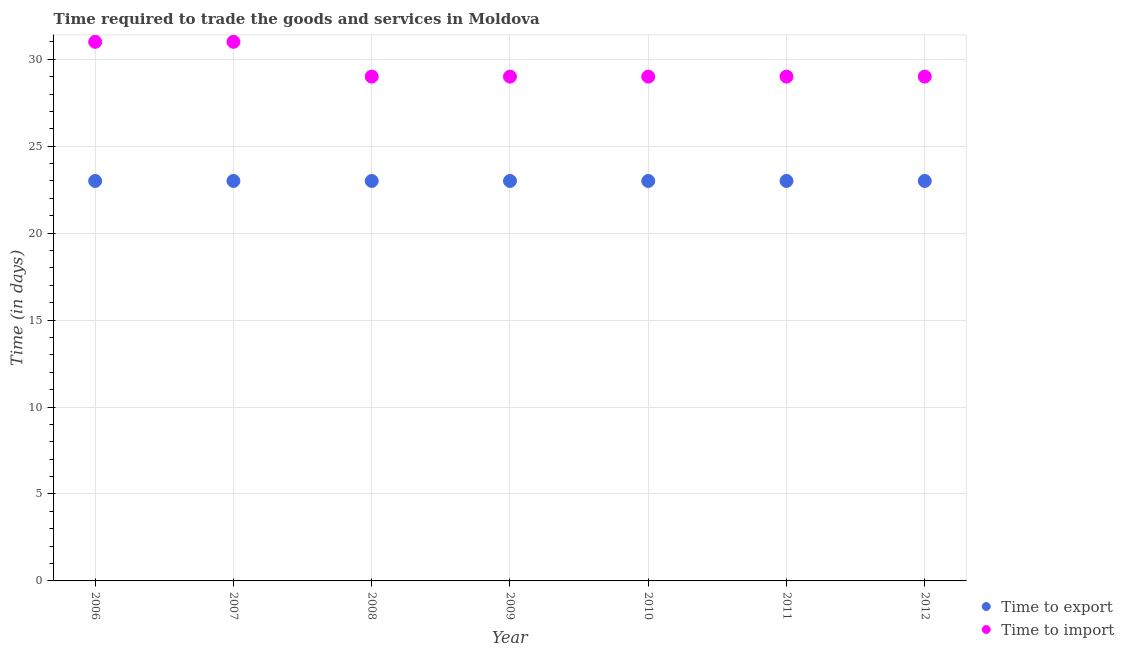How many different coloured dotlines are there?
Ensure brevity in your answer.  2. Is the number of dotlines equal to the number of legend labels?
Offer a terse response. Yes. What is the time to import in 2007?
Offer a very short reply. 31. Across all years, what is the maximum time to import?
Your answer should be very brief. 31. Across all years, what is the minimum time to import?
Your answer should be compact. 29. What is the total time to export in the graph?
Provide a short and direct response. 161. In the year 2007, what is the difference between the time to import and time to export?
Your response must be concise. 8. What is the ratio of the time to import in 2011 to that in 2012?
Your response must be concise. 1. Is the time to import in 2008 less than that in 2009?
Keep it short and to the point. No. In how many years, is the time to export greater than the average time to export taken over all years?
Your answer should be compact. 0. Is the sum of the time to export in 2007 and 2011 greater than the maximum time to import across all years?
Give a very brief answer. Yes. Does the time to export monotonically increase over the years?
Ensure brevity in your answer.  No. Is the time to export strictly greater than the time to import over the years?
Make the answer very short. No. How many dotlines are there?
Make the answer very short. 2. How many years are there in the graph?
Offer a terse response. 7. What is the difference between two consecutive major ticks on the Y-axis?
Provide a short and direct response. 5. Does the graph contain grids?
Your answer should be very brief. Yes. Where does the legend appear in the graph?
Make the answer very short. Bottom right. How many legend labels are there?
Make the answer very short. 2. How are the legend labels stacked?
Ensure brevity in your answer.  Vertical. What is the title of the graph?
Offer a very short reply. Time required to trade the goods and services in Moldova. What is the label or title of the Y-axis?
Keep it short and to the point. Time (in days). What is the Time (in days) of Time to export in 2006?
Provide a short and direct response. 23. What is the Time (in days) in Time to export in 2007?
Your response must be concise. 23. What is the Time (in days) of Time to import in 2007?
Provide a succinct answer. 31. What is the Time (in days) in Time to import in 2008?
Make the answer very short. 29. What is the Time (in days) in Time to export in 2010?
Provide a short and direct response. 23. What is the Time (in days) in Time to import in 2011?
Your answer should be compact. 29. Across all years, what is the maximum Time (in days) of Time to export?
Provide a short and direct response. 23. Across all years, what is the minimum Time (in days) in Time to export?
Your answer should be very brief. 23. What is the total Time (in days) in Time to export in the graph?
Your answer should be very brief. 161. What is the total Time (in days) of Time to import in the graph?
Your answer should be very brief. 207. What is the difference between the Time (in days) in Time to export in 2006 and that in 2008?
Ensure brevity in your answer.  0. What is the difference between the Time (in days) in Time to import in 2006 and that in 2008?
Offer a terse response. 2. What is the difference between the Time (in days) of Time to export in 2006 and that in 2009?
Offer a terse response. 0. What is the difference between the Time (in days) in Time to export in 2006 and that in 2010?
Ensure brevity in your answer.  0. What is the difference between the Time (in days) of Time to export in 2006 and that in 2011?
Make the answer very short. 0. What is the difference between the Time (in days) in Time to export in 2007 and that in 2010?
Give a very brief answer. 0. What is the difference between the Time (in days) in Time to export in 2007 and that in 2011?
Provide a short and direct response. 0. What is the difference between the Time (in days) in Time to import in 2007 and that in 2011?
Your response must be concise. 2. What is the difference between the Time (in days) of Time to export in 2007 and that in 2012?
Keep it short and to the point. 0. What is the difference between the Time (in days) in Time to import in 2008 and that in 2009?
Provide a short and direct response. 0. What is the difference between the Time (in days) of Time to import in 2008 and that in 2011?
Your answer should be compact. 0. What is the difference between the Time (in days) in Time to export in 2008 and that in 2012?
Offer a terse response. 0. What is the difference between the Time (in days) of Time to import in 2008 and that in 2012?
Make the answer very short. 0. What is the difference between the Time (in days) in Time to import in 2009 and that in 2011?
Offer a terse response. 0. What is the difference between the Time (in days) of Time to import in 2009 and that in 2012?
Keep it short and to the point. 0. What is the difference between the Time (in days) in Time to export in 2010 and that in 2011?
Your response must be concise. 0. What is the difference between the Time (in days) of Time to import in 2010 and that in 2012?
Ensure brevity in your answer.  0. What is the difference between the Time (in days) of Time to export in 2011 and that in 2012?
Give a very brief answer. 0. What is the difference between the Time (in days) of Time to export in 2006 and the Time (in days) of Time to import in 2008?
Give a very brief answer. -6. What is the difference between the Time (in days) of Time to export in 2006 and the Time (in days) of Time to import in 2009?
Your answer should be compact. -6. What is the difference between the Time (in days) of Time to export in 2006 and the Time (in days) of Time to import in 2010?
Your response must be concise. -6. What is the difference between the Time (in days) in Time to export in 2006 and the Time (in days) in Time to import in 2012?
Provide a short and direct response. -6. What is the difference between the Time (in days) of Time to export in 2008 and the Time (in days) of Time to import in 2010?
Provide a short and direct response. -6. What is the difference between the Time (in days) in Time to export in 2008 and the Time (in days) in Time to import in 2011?
Your answer should be compact. -6. What is the difference between the Time (in days) in Time to export in 2008 and the Time (in days) in Time to import in 2012?
Give a very brief answer. -6. What is the difference between the Time (in days) of Time to export in 2010 and the Time (in days) of Time to import in 2011?
Offer a very short reply. -6. What is the difference between the Time (in days) of Time to export in 2010 and the Time (in days) of Time to import in 2012?
Your answer should be compact. -6. What is the difference between the Time (in days) in Time to export in 2011 and the Time (in days) in Time to import in 2012?
Offer a very short reply. -6. What is the average Time (in days) of Time to export per year?
Keep it short and to the point. 23. What is the average Time (in days) of Time to import per year?
Your response must be concise. 29.57. In the year 2008, what is the difference between the Time (in days) of Time to export and Time (in days) of Time to import?
Offer a terse response. -6. In the year 2009, what is the difference between the Time (in days) of Time to export and Time (in days) of Time to import?
Your answer should be compact. -6. In the year 2010, what is the difference between the Time (in days) in Time to export and Time (in days) in Time to import?
Your answer should be very brief. -6. What is the ratio of the Time (in days) in Time to import in 2006 to that in 2007?
Ensure brevity in your answer.  1. What is the ratio of the Time (in days) in Time to import in 2006 to that in 2008?
Make the answer very short. 1.07. What is the ratio of the Time (in days) in Time to import in 2006 to that in 2009?
Make the answer very short. 1.07. What is the ratio of the Time (in days) in Time to export in 2006 to that in 2010?
Offer a terse response. 1. What is the ratio of the Time (in days) in Time to import in 2006 to that in 2010?
Your answer should be compact. 1.07. What is the ratio of the Time (in days) of Time to import in 2006 to that in 2011?
Give a very brief answer. 1.07. What is the ratio of the Time (in days) in Time to export in 2006 to that in 2012?
Ensure brevity in your answer.  1. What is the ratio of the Time (in days) of Time to import in 2006 to that in 2012?
Your answer should be compact. 1.07. What is the ratio of the Time (in days) of Time to export in 2007 to that in 2008?
Give a very brief answer. 1. What is the ratio of the Time (in days) of Time to import in 2007 to that in 2008?
Offer a terse response. 1.07. What is the ratio of the Time (in days) in Time to import in 2007 to that in 2009?
Offer a very short reply. 1.07. What is the ratio of the Time (in days) in Time to export in 2007 to that in 2010?
Keep it short and to the point. 1. What is the ratio of the Time (in days) in Time to import in 2007 to that in 2010?
Provide a succinct answer. 1.07. What is the ratio of the Time (in days) of Time to import in 2007 to that in 2011?
Keep it short and to the point. 1.07. What is the ratio of the Time (in days) of Time to import in 2007 to that in 2012?
Your answer should be compact. 1.07. What is the ratio of the Time (in days) in Time to export in 2008 to that in 2009?
Give a very brief answer. 1. What is the ratio of the Time (in days) of Time to export in 2008 to that in 2010?
Ensure brevity in your answer.  1. What is the ratio of the Time (in days) in Time to import in 2008 to that in 2011?
Your answer should be very brief. 1. What is the ratio of the Time (in days) of Time to export in 2008 to that in 2012?
Your answer should be very brief. 1. What is the ratio of the Time (in days) of Time to import in 2009 to that in 2010?
Provide a succinct answer. 1. What is the ratio of the Time (in days) of Time to export in 2010 to that in 2012?
Keep it short and to the point. 1. What is the ratio of the Time (in days) of Time to export in 2011 to that in 2012?
Your answer should be compact. 1. What is the difference between the highest and the second highest Time (in days) of Time to export?
Give a very brief answer. 0. What is the difference between the highest and the second highest Time (in days) in Time to import?
Offer a very short reply. 0. 